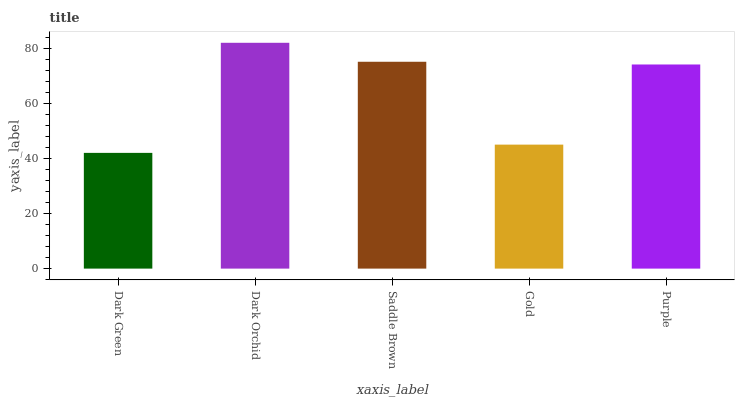Is Dark Green the minimum?
Answer yes or no. Yes. Is Dark Orchid the maximum?
Answer yes or no. Yes. Is Saddle Brown the minimum?
Answer yes or no. No. Is Saddle Brown the maximum?
Answer yes or no. No. Is Dark Orchid greater than Saddle Brown?
Answer yes or no. Yes. Is Saddle Brown less than Dark Orchid?
Answer yes or no. Yes. Is Saddle Brown greater than Dark Orchid?
Answer yes or no. No. Is Dark Orchid less than Saddle Brown?
Answer yes or no. No. Is Purple the high median?
Answer yes or no. Yes. Is Purple the low median?
Answer yes or no. Yes. Is Dark Orchid the high median?
Answer yes or no. No. Is Saddle Brown the low median?
Answer yes or no. No. 